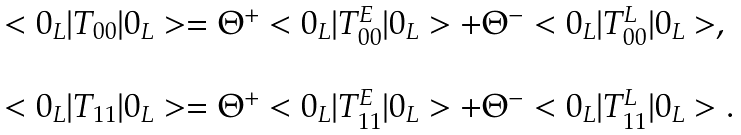Convert formula to latex. <formula><loc_0><loc_0><loc_500><loc_500>\begin{array} { l l } < 0 _ { L } | T _ { 0 0 } | 0 _ { L } > = \Theta ^ { + } < 0 _ { L } | T _ { 0 0 } ^ { E } | 0 _ { L } > + \Theta ^ { - } < 0 _ { L } | T _ { 0 0 } ^ { L } | 0 _ { L } > , \\ \\ < 0 _ { L } | T _ { 1 1 } | 0 _ { L } > = \Theta ^ { + } < 0 _ { L } | T _ { 1 1 } ^ { E } | 0 _ { L } > + \Theta ^ { - } < 0 _ { L } | T _ { 1 1 } ^ { L } | 0 _ { L } > . \end{array}</formula> 